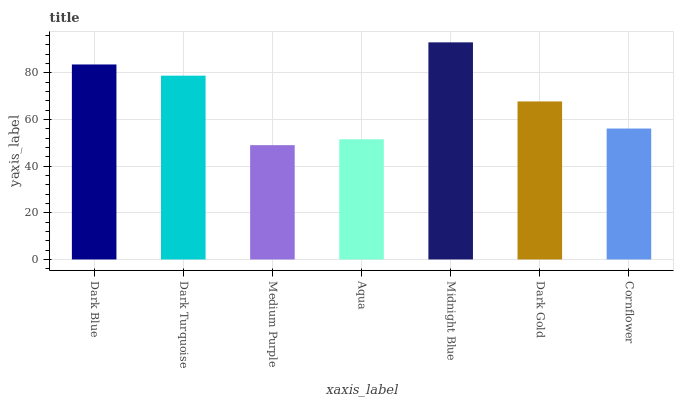Is Dark Turquoise the minimum?
Answer yes or no. No. Is Dark Turquoise the maximum?
Answer yes or no. No. Is Dark Blue greater than Dark Turquoise?
Answer yes or no. Yes. Is Dark Turquoise less than Dark Blue?
Answer yes or no. Yes. Is Dark Turquoise greater than Dark Blue?
Answer yes or no. No. Is Dark Blue less than Dark Turquoise?
Answer yes or no. No. Is Dark Gold the high median?
Answer yes or no. Yes. Is Dark Gold the low median?
Answer yes or no. Yes. Is Dark Turquoise the high median?
Answer yes or no. No. Is Cornflower the low median?
Answer yes or no. No. 